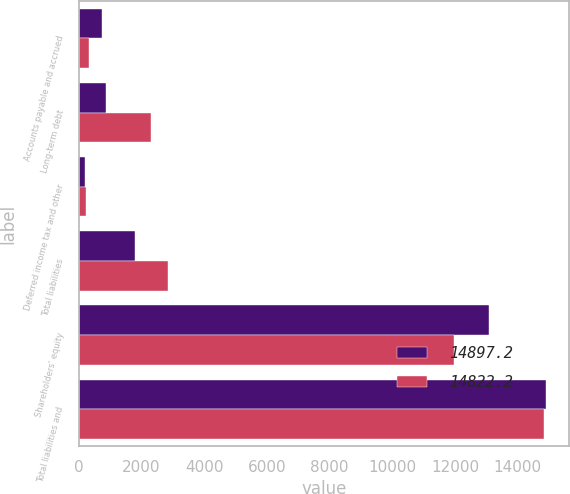<chart> <loc_0><loc_0><loc_500><loc_500><stacked_bar_chart><ecel><fcel>Accounts payable and accrued<fcel>Long-term debt<fcel>Deferred income tax and other<fcel>Total liabilities<fcel>Shareholders' equity<fcel>Total liabilities and<nl><fcel>14897.2<fcel>737.6<fcel>864.9<fcel>202.6<fcel>1805.1<fcel>13092.1<fcel>14897.2<nl><fcel>14822.2<fcel>319.9<fcel>2305.2<fcel>227.2<fcel>2852.3<fcel>11969.9<fcel>14822.2<nl></chart> 